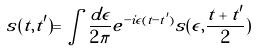<formula> <loc_0><loc_0><loc_500><loc_500>s ( t , t ^ { \prime } ) = \int \frac { d \epsilon } { 2 \pi } e ^ { - i \epsilon ( t - t ^ { \prime } ) } s ( \epsilon , \frac { t + t ^ { \prime } } { 2 } )</formula> 